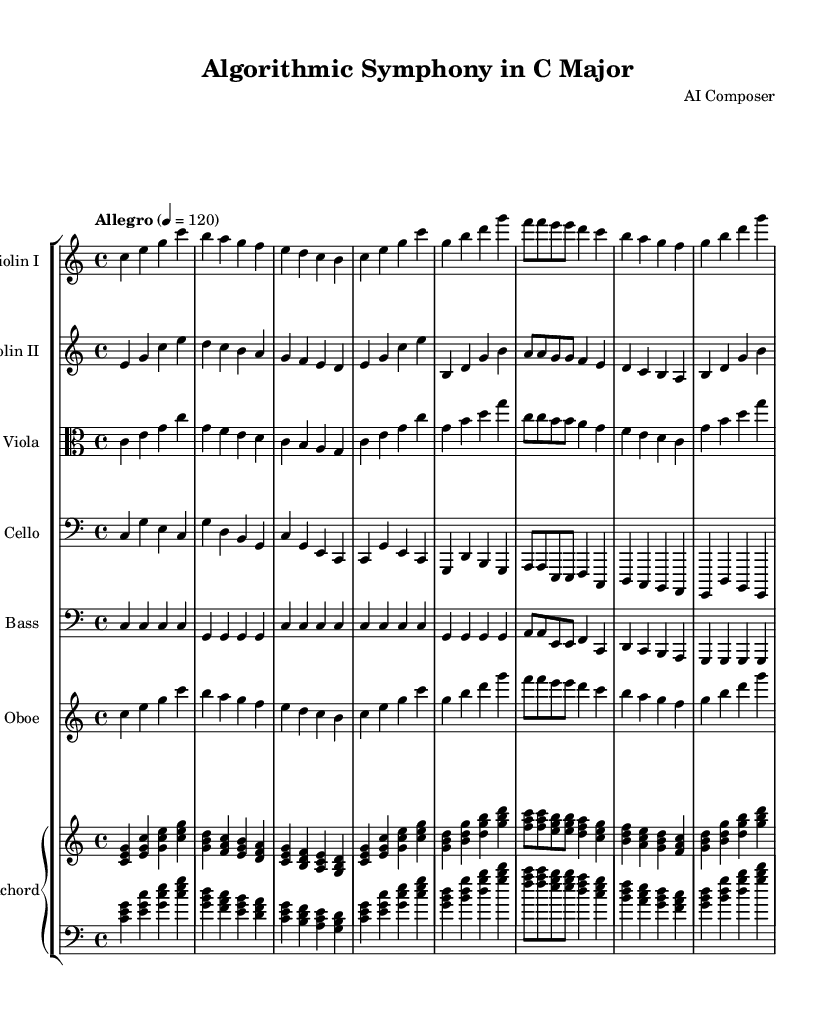What is the key signature of this music? The key signature is C major, which is indicated by the absence of sharps or flats in the music.
Answer: C major What is the time signature of this piece? The time signature is located at the beginning of the score. Here, it is marked as 4/4, which means there are four beats in each measure with a quarter note receiving one beat.
Answer: 4/4 What is the tempo marking? The tempo marking is usually indicated at the beginning of the piece. In this case, the score states "Allegro" at a tempo of 120 beats per minute, suggesting a fast pace.
Answer: Allegro Which instruments are included in the orchestration? By examining the score, instruments can be identified from the staff labels. The listed instruments are Violin I, Violin II, Viola, Cello, Double Bass, Oboe, and Harpsichord.
Answer: Violin I, Violin II, Viola, Cello, Double Bass, Oboe, Harpsichord What is the purpose of the harpsichord in this piece? In Baroque orchestral works, the harpsichord often serves as a continuo instrument, providing harmonic support alongside melodic lines. Its part typically includes both upper and lower registers, enhancing the texture of the music.
Answer: Continuo instrument How many measures are presented in the score snippet? Counting the measures indicated in the score, there are a total of 15 measures visible across the different instrument staves provided. Each measure is separated by vertical lines, making it easy to count.
Answer: 15 Which section of the orchestra typically has the highest pitch? The Oboe is generally known for its bright, high-pitched sound compared to the string instruments presented in the score, making it the section with the highest pitch here.
Answer: Oboe 